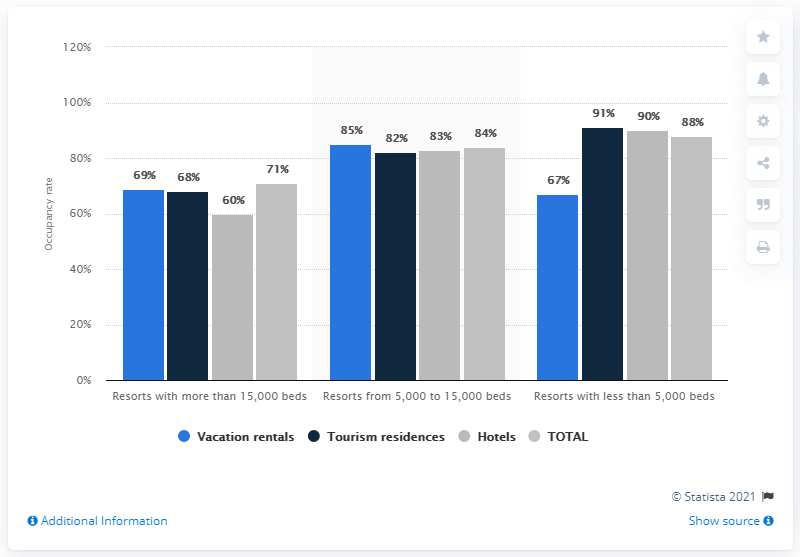Draw attention to some important aspects in this diagram. The occupancy rate of ski resorts in 2016 was 60%. 